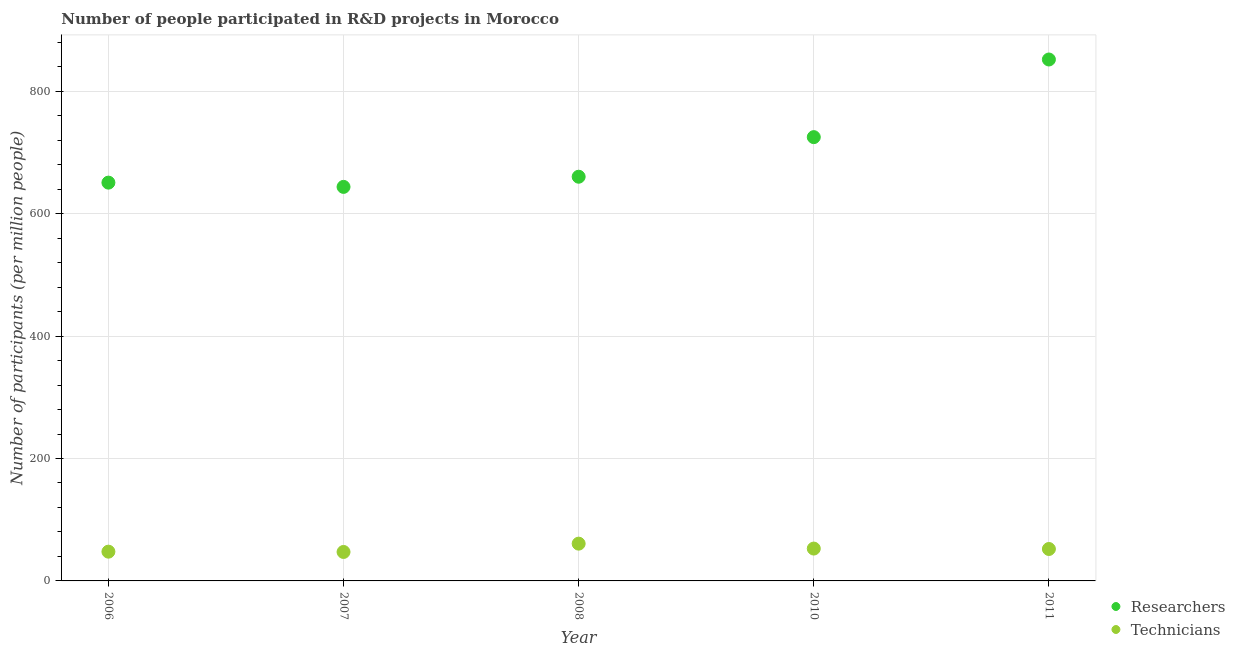How many different coloured dotlines are there?
Your answer should be very brief. 2. Is the number of dotlines equal to the number of legend labels?
Ensure brevity in your answer.  Yes. What is the number of researchers in 2011?
Your answer should be compact. 851.9. Across all years, what is the maximum number of researchers?
Your answer should be compact. 851.9. Across all years, what is the minimum number of technicians?
Give a very brief answer. 47.31. What is the total number of technicians in the graph?
Give a very brief answer. 261.01. What is the difference between the number of researchers in 2008 and that in 2011?
Your answer should be compact. -191.53. What is the difference between the number of researchers in 2011 and the number of technicians in 2008?
Make the answer very short. 791.01. What is the average number of researchers per year?
Provide a short and direct response. 706.37. In the year 2011, what is the difference between the number of researchers and number of technicians?
Provide a short and direct response. 799.74. In how many years, is the number of technicians greater than 520?
Give a very brief answer. 0. What is the ratio of the number of technicians in 2008 to that in 2011?
Your response must be concise. 1.17. Is the number of researchers in 2007 less than that in 2011?
Offer a terse response. Yes. Is the difference between the number of technicians in 2007 and 2008 greater than the difference between the number of researchers in 2007 and 2008?
Offer a terse response. Yes. What is the difference between the highest and the second highest number of technicians?
Give a very brief answer. 8.04. What is the difference between the highest and the lowest number of researchers?
Provide a succinct answer. 208.14. In how many years, is the number of technicians greater than the average number of technicians taken over all years?
Give a very brief answer. 2. Is the sum of the number of technicians in 2008 and 2010 greater than the maximum number of researchers across all years?
Offer a very short reply. No. Does the number of technicians monotonically increase over the years?
Offer a terse response. No. Is the number of researchers strictly greater than the number of technicians over the years?
Provide a succinct answer. Yes. Is the number of technicians strictly less than the number of researchers over the years?
Your response must be concise. Yes. How many dotlines are there?
Keep it short and to the point. 2. Are the values on the major ticks of Y-axis written in scientific E-notation?
Make the answer very short. No. Does the graph contain grids?
Your response must be concise. Yes. How many legend labels are there?
Offer a terse response. 2. What is the title of the graph?
Offer a very short reply. Number of people participated in R&D projects in Morocco. Does "Nonresident" appear as one of the legend labels in the graph?
Make the answer very short. No. What is the label or title of the X-axis?
Offer a terse response. Year. What is the label or title of the Y-axis?
Ensure brevity in your answer.  Number of participants (per million people). What is the Number of participants (per million people) in Researchers in 2006?
Offer a terse response. 650.74. What is the Number of participants (per million people) of Technicians in 2006?
Provide a succinct answer. 47.8. What is the Number of participants (per million people) in Researchers in 2007?
Offer a very short reply. 643.76. What is the Number of participants (per million people) in Technicians in 2007?
Your answer should be very brief. 47.31. What is the Number of participants (per million people) in Researchers in 2008?
Keep it short and to the point. 660.37. What is the Number of participants (per million people) of Technicians in 2008?
Give a very brief answer. 60.89. What is the Number of participants (per million people) of Researchers in 2010?
Your answer should be compact. 725.06. What is the Number of participants (per million people) of Technicians in 2010?
Your answer should be compact. 52.85. What is the Number of participants (per million people) of Researchers in 2011?
Your answer should be very brief. 851.9. What is the Number of participants (per million people) in Technicians in 2011?
Your answer should be very brief. 52.16. Across all years, what is the maximum Number of participants (per million people) in Researchers?
Provide a succinct answer. 851.9. Across all years, what is the maximum Number of participants (per million people) in Technicians?
Give a very brief answer. 60.89. Across all years, what is the minimum Number of participants (per million people) in Researchers?
Make the answer very short. 643.76. Across all years, what is the minimum Number of participants (per million people) in Technicians?
Your answer should be compact. 47.31. What is the total Number of participants (per million people) in Researchers in the graph?
Provide a succinct answer. 3531.83. What is the total Number of participants (per million people) in Technicians in the graph?
Give a very brief answer. 261.01. What is the difference between the Number of participants (per million people) of Researchers in 2006 and that in 2007?
Your answer should be very brief. 6.97. What is the difference between the Number of participants (per million people) in Technicians in 2006 and that in 2007?
Offer a terse response. 0.49. What is the difference between the Number of participants (per million people) of Researchers in 2006 and that in 2008?
Make the answer very short. -9.64. What is the difference between the Number of participants (per million people) in Technicians in 2006 and that in 2008?
Offer a very short reply. -13.09. What is the difference between the Number of participants (per million people) in Researchers in 2006 and that in 2010?
Keep it short and to the point. -74.32. What is the difference between the Number of participants (per million people) in Technicians in 2006 and that in 2010?
Ensure brevity in your answer.  -5.05. What is the difference between the Number of participants (per million people) in Researchers in 2006 and that in 2011?
Provide a short and direct response. -201.17. What is the difference between the Number of participants (per million people) in Technicians in 2006 and that in 2011?
Keep it short and to the point. -4.37. What is the difference between the Number of participants (per million people) in Researchers in 2007 and that in 2008?
Provide a short and direct response. -16.61. What is the difference between the Number of participants (per million people) of Technicians in 2007 and that in 2008?
Make the answer very short. -13.59. What is the difference between the Number of participants (per million people) of Researchers in 2007 and that in 2010?
Keep it short and to the point. -81.29. What is the difference between the Number of participants (per million people) of Technicians in 2007 and that in 2010?
Provide a succinct answer. -5.55. What is the difference between the Number of participants (per million people) in Researchers in 2007 and that in 2011?
Make the answer very short. -208.14. What is the difference between the Number of participants (per million people) in Technicians in 2007 and that in 2011?
Ensure brevity in your answer.  -4.86. What is the difference between the Number of participants (per million people) in Researchers in 2008 and that in 2010?
Offer a terse response. -64.69. What is the difference between the Number of participants (per million people) of Technicians in 2008 and that in 2010?
Your answer should be very brief. 8.04. What is the difference between the Number of participants (per million people) of Researchers in 2008 and that in 2011?
Offer a terse response. -191.53. What is the difference between the Number of participants (per million people) of Technicians in 2008 and that in 2011?
Offer a terse response. 8.73. What is the difference between the Number of participants (per million people) of Researchers in 2010 and that in 2011?
Make the answer very short. -126.84. What is the difference between the Number of participants (per million people) in Technicians in 2010 and that in 2011?
Your answer should be compact. 0.69. What is the difference between the Number of participants (per million people) of Researchers in 2006 and the Number of participants (per million people) of Technicians in 2007?
Provide a short and direct response. 603.43. What is the difference between the Number of participants (per million people) of Researchers in 2006 and the Number of participants (per million people) of Technicians in 2008?
Your answer should be compact. 589.84. What is the difference between the Number of participants (per million people) of Researchers in 2006 and the Number of participants (per million people) of Technicians in 2010?
Offer a terse response. 597.88. What is the difference between the Number of participants (per million people) in Researchers in 2006 and the Number of participants (per million people) in Technicians in 2011?
Keep it short and to the point. 598.57. What is the difference between the Number of participants (per million people) in Researchers in 2007 and the Number of participants (per million people) in Technicians in 2008?
Your answer should be compact. 582.87. What is the difference between the Number of participants (per million people) in Researchers in 2007 and the Number of participants (per million people) in Technicians in 2010?
Make the answer very short. 590.91. What is the difference between the Number of participants (per million people) in Researchers in 2007 and the Number of participants (per million people) in Technicians in 2011?
Ensure brevity in your answer.  591.6. What is the difference between the Number of participants (per million people) of Researchers in 2008 and the Number of participants (per million people) of Technicians in 2010?
Your response must be concise. 607.52. What is the difference between the Number of participants (per million people) in Researchers in 2008 and the Number of participants (per million people) in Technicians in 2011?
Your answer should be very brief. 608.21. What is the difference between the Number of participants (per million people) of Researchers in 2010 and the Number of participants (per million people) of Technicians in 2011?
Your answer should be very brief. 672.89. What is the average Number of participants (per million people) of Researchers per year?
Provide a succinct answer. 706.37. What is the average Number of participants (per million people) of Technicians per year?
Your answer should be compact. 52.2. In the year 2006, what is the difference between the Number of participants (per million people) in Researchers and Number of participants (per million people) in Technicians?
Your answer should be compact. 602.94. In the year 2007, what is the difference between the Number of participants (per million people) in Researchers and Number of participants (per million people) in Technicians?
Your response must be concise. 596.46. In the year 2008, what is the difference between the Number of participants (per million people) in Researchers and Number of participants (per million people) in Technicians?
Offer a very short reply. 599.48. In the year 2010, what is the difference between the Number of participants (per million people) in Researchers and Number of participants (per million people) in Technicians?
Offer a very short reply. 672.21. In the year 2011, what is the difference between the Number of participants (per million people) in Researchers and Number of participants (per million people) in Technicians?
Your response must be concise. 799.74. What is the ratio of the Number of participants (per million people) of Researchers in 2006 to that in 2007?
Provide a short and direct response. 1.01. What is the ratio of the Number of participants (per million people) of Technicians in 2006 to that in 2007?
Ensure brevity in your answer.  1.01. What is the ratio of the Number of participants (per million people) of Researchers in 2006 to that in 2008?
Your answer should be very brief. 0.99. What is the ratio of the Number of participants (per million people) of Technicians in 2006 to that in 2008?
Provide a succinct answer. 0.79. What is the ratio of the Number of participants (per million people) in Researchers in 2006 to that in 2010?
Offer a very short reply. 0.9. What is the ratio of the Number of participants (per million people) of Technicians in 2006 to that in 2010?
Your response must be concise. 0.9. What is the ratio of the Number of participants (per million people) of Researchers in 2006 to that in 2011?
Ensure brevity in your answer.  0.76. What is the ratio of the Number of participants (per million people) of Technicians in 2006 to that in 2011?
Provide a succinct answer. 0.92. What is the ratio of the Number of participants (per million people) of Researchers in 2007 to that in 2008?
Keep it short and to the point. 0.97. What is the ratio of the Number of participants (per million people) in Technicians in 2007 to that in 2008?
Your answer should be compact. 0.78. What is the ratio of the Number of participants (per million people) in Researchers in 2007 to that in 2010?
Ensure brevity in your answer.  0.89. What is the ratio of the Number of participants (per million people) of Technicians in 2007 to that in 2010?
Provide a succinct answer. 0.9. What is the ratio of the Number of participants (per million people) in Researchers in 2007 to that in 2011?
Provide a short and direct response. 0.76. What is the ratio of the Number of participants (per million people) of Technicians in 2007 to that in 2011?
Keep it short and to the point. 0.91. What is the ratio of the Number of participants (per million people) of Researchers in 2008 to that in 2010?
Provide a succinct answer. 0.91. What is the ratio of the Number of participants (per million people) of Technicians in 2008 to that in 2010?
Give a very brief answer. 1.15. What is the ratio of the Number of participants (per million people) of Researchers in 2008 to that in 2011?
Make the answer very short. 0.78. What is the ratio of the Number of participants (per million people) in Technicians in 2008 to that in 2011?
Your response must be concise. 1.17. What is the ratio of the Number of participants (per million people) of Researchers in 2010 to that in 2011?
Ensure brevity in your answer.  0.85. What is the ratio of the Number of participants (per million people) in Technicians in 2010 to that in 2011?
Provide a succinct answer. 1.01. What is the difference between the highest and the second highest Number of participants (per million people) of Researchers?
Offer a terse response. 126.84. What is the difference between the highest and the second highest Number of participants (per million people) in Technicians?
Your answer should be very brief. 8.04. What is the difference between the highest and the lowest Number of participants (per million people) in Researchers?
Make the answer very short. 208.14. What is the difference between the highest and the lowest Number of participants (per million people) in Technicians?
Your answer should be very brief. 13.59. 